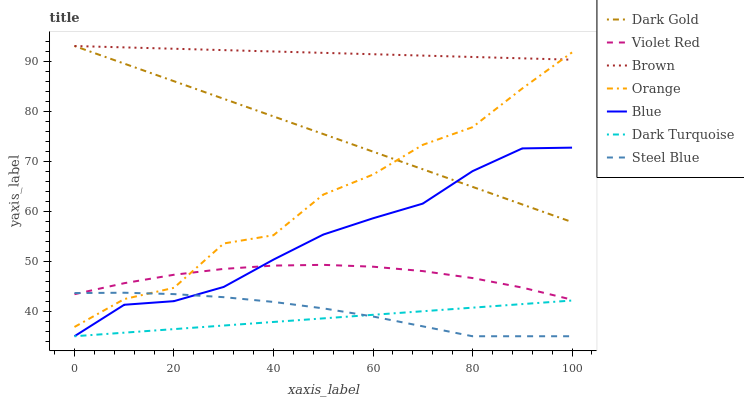Does Dark Turquoise have the minimum area under the curve?
Answer yes or no. Yes. Does Brown have the maximum area under the curve?
Answer yes or no. Yes. Does Violet Red have the minimum area under the curve?
Answer yes or no. No. Does Violet Red have the maximum area under the curve?
Answer yes or no. No. Is Dark Turquoise the smoothest?
Answer yes or no. Yes. Is Orange the roughest?
Answer yes or no. Yes. Is Brown the smoothest?
Answer yes or no. No. Is Brown the roughest?
Answer yes or no. No. Does Blue have the lowest value?
Answer yes or no. Yes. Does Violet Red have the lowest value?
Answer yes or no. No. Does Dark Gold have the highest value?
Answer yes or no. Yes. Does Violet Red have the highest value?
Answer yes or no. No. Is Dark Turquoise less than Brown?
Answer yes or no. Yes. Is Brown greater than Violet Red?
Answer yes or no. Yes. Does Steel Blue intersect Dark Turquoise?
Answer yes or no. Yes. Is Steel Blue less than Dark Turquoise?
Answer yes or no. No. Is Steel Blue greater than Dark Turquoise?
Answer yes or no. No. Does Dark Turquoise intersect Brown?
Answer yes or no. No. 